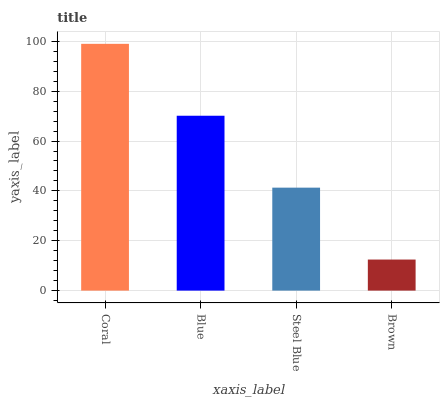Is Brown the minimum?
Answer yes or no. Yes. Is Coral the maximum?
Answer yes or no. Yes. Is Blue the minimum?
Answer yes or no. No. Is Blue the maximum?
Answer yes or no. No. Is Coral greater than Blue?
Answer yes or no. Yes. Is Blue less than Coral?
Answer yes or no. Yes. Is Blue greater than Coral?
Answer yes or no. No. Is Coral less than Blue?
Answer yes or no. No. Is Blue the high median?
Answer yes or no. Yes. Is Steel Blue the low median?
Answer yes or no. Yes. Is Coral the high median?
Answer yes or no. No. Is Coral the low median?
Answer yes or no. No. 